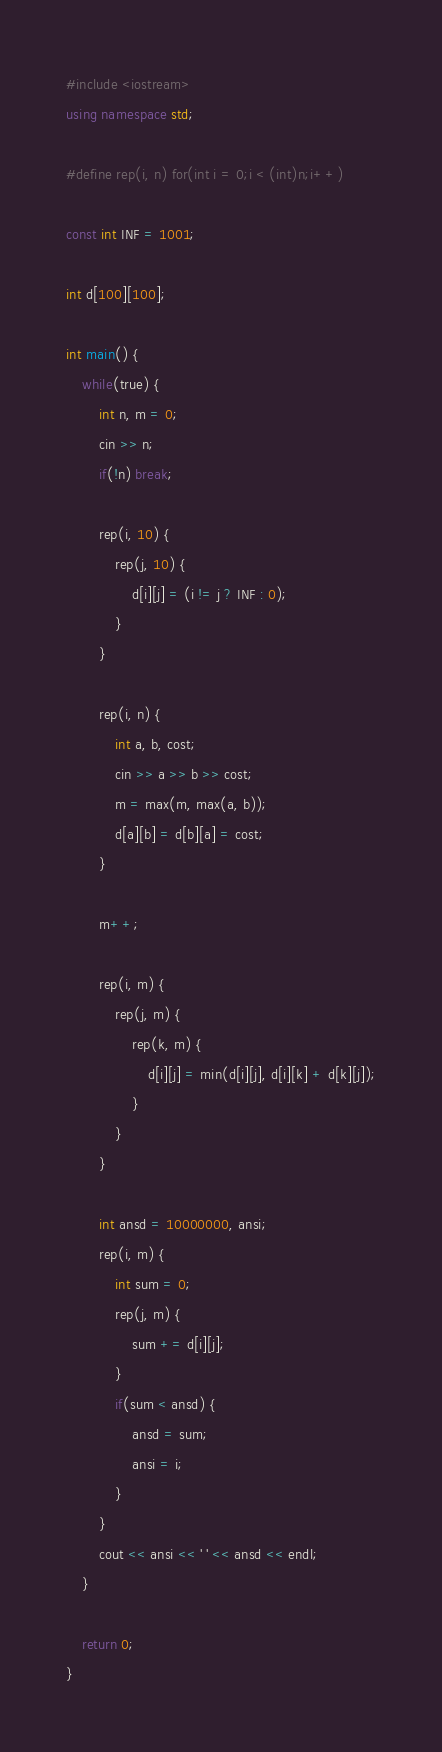<code> <loc_0><loc_0><loc_500><loc_500><_C++_>#include <iostream>
using namespace std;

#define rep(i, n) for(int i = 0;i < (int)n;i++)

const int INF = 1001;

int d[100][100];

int main() {
    while(true) {
        int n, m = 0;
        cin >> n;
        if(!n) break;

        rep(i, 10) {
            rep(j, 10) {
                d[i][j] = (i != j ? INF : 0);
            }
        }

        rep(i, n) {
            int a, b, cost;
            cin >> a >> b >> cost;
            m = max(m, max(a, b));
            d[a][b] = d[b][a] = cost;
        }

        m++;

        rep(i, m) {
            rep(j, m) {
                rep(k, m) {
                    d[i][j] = min(d[i][j], d[i][k] + d[k][j]);
                }
            }
        }

        int ansd = 10000000, ansi;
        rep(i, m) {
            int sum = 0;
            rep(j, m) {
                sum += d[i][j];
            }
            if(sum < ansd) {
                ansd = sum;
                ansi = i;
            }
        }
        cout << ansi << ' ' << ansd << endl;
    }

    return 0;
}</code> 